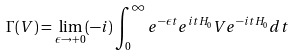Convert formula to latex. <formula><loc_0><loc_0><loc_500><loc_500>\Gamma ( V ) = \lim _ { \epsilon \to + 0 } ( - i ) \int _ { 0 } ^ { \infty } e ^ { - \epsilon t } e ^ { i t H _ { 0 } } V e ^ { - i t H _ { 0 } } d t</formula> 